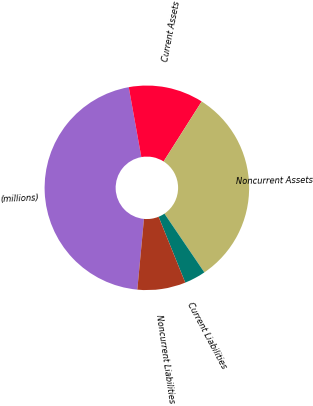Convert chart. <chart><loc_0><loc_0><loc_500><loc_500><pie_chart><fcel>(millions)<fcel>Current Assets<fcel>Noncurrent Assets<fcel>Current Liabilities<fcel>Noncurrent Liabilities<nl><fcel>45.68%<fcel>11.84%<fcel>31.5%<fcel>3.38%<fcel>7.61%<nl></chart> 